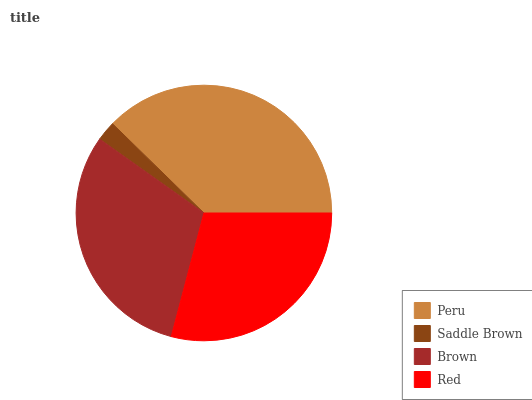Is Saddle Brown the minimum?
Answer yes or no. Yes. Is Peru the maximum?
Answer yes or no. Yes. Is Brown the minimum?
Answer yes or no. No. Is Brown the maximum?
Answer yes or no. No. Is Brown greater than Saddle Brown?
Answer yes or no. Yes. Is Saddle Brown less than Brown?
Answer yes or no. Yes. Is Saddle Brown greater than Brown?
Answer yes or no. No. Is Brown less than Saddle Brown?
Answer yes or no. No. Is Brown the high median?
Answer yes or no. Yes. Is Red the low median?
Answer yes or no. Yes. Is Red the high median?
Answer yes or no. No. Is Peru the low median?
Answer yes or no. No. 